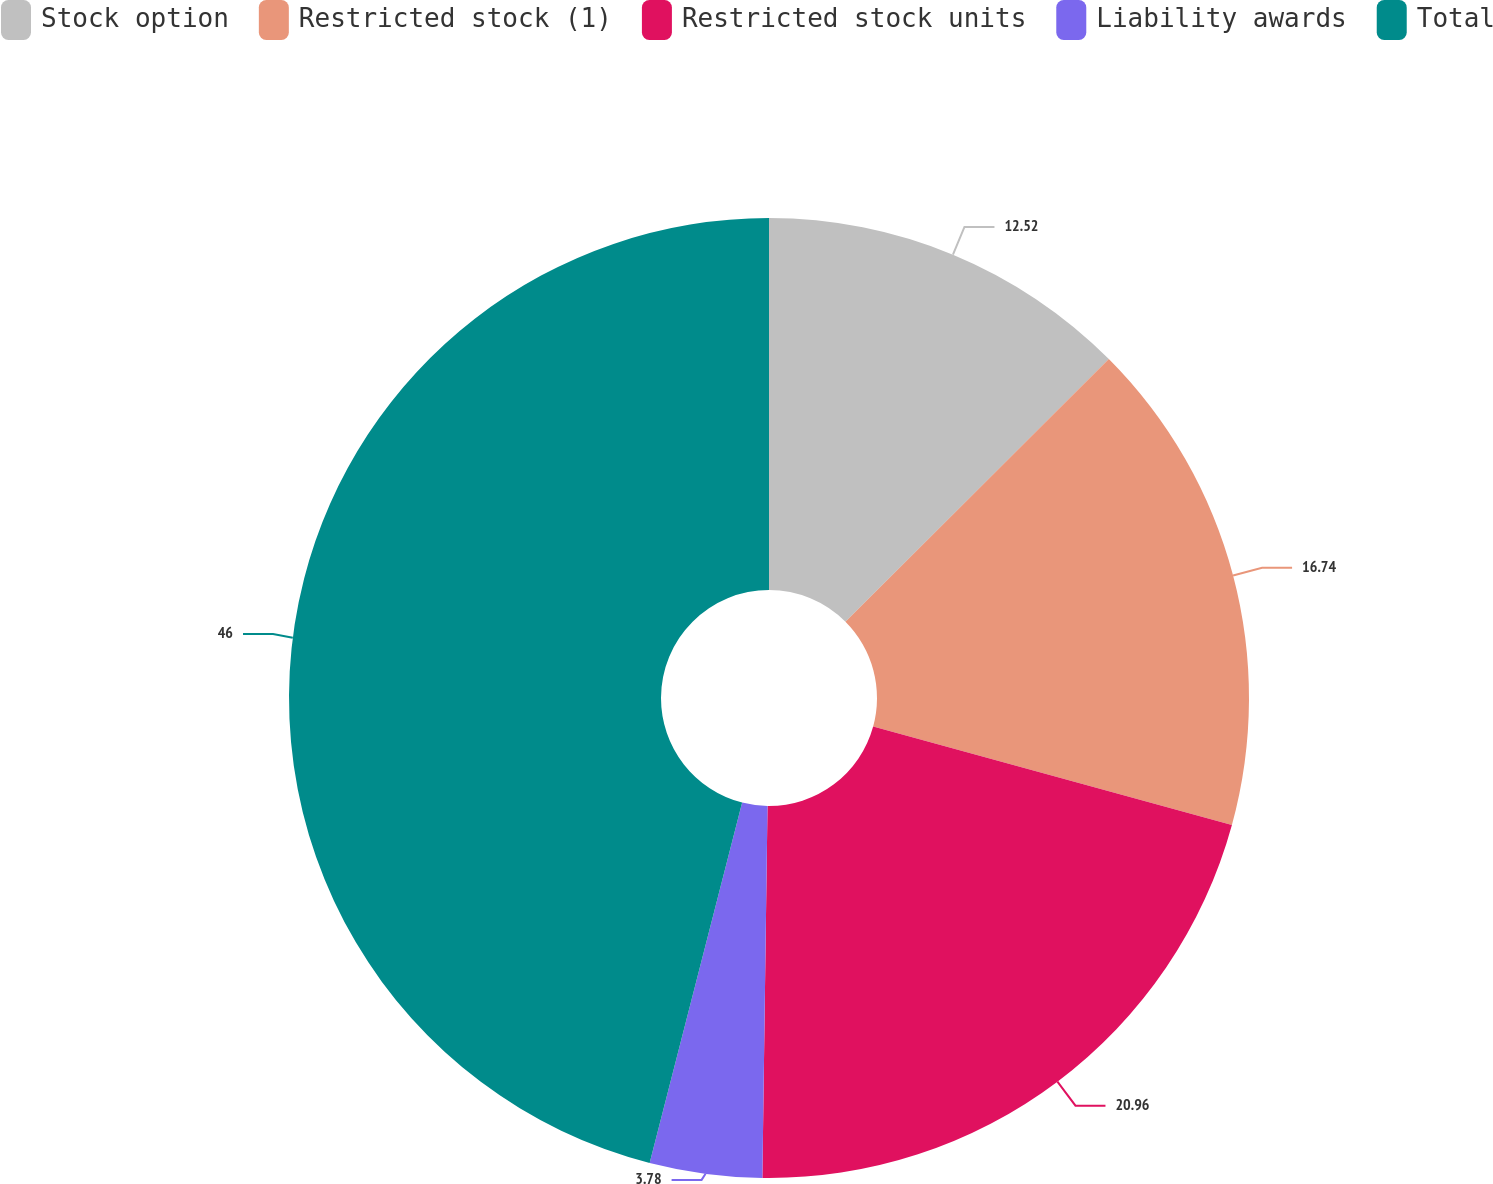Convert chart. <chart><loc_0><loc_0><loc_500><loc_500><pie_chart><fcel>Stock option<fcel>Restricted stock (1)<fcel>Restricted stock units<fcel>Liability awards<fcel>Total<nl><fcel>12.52%<fcel>16.74%<fcel>20.96%<fcel>3.78%<fcel>46.0%<nl></chart> 